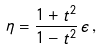Convert formula to latex. <formula><loc_0><loc_0><loc_500><loc_500>\eta = \frac { 1 + t ^ { 2 } } { 1 - t ^ { 2 } } \, \epsilon \, ,</formula> 